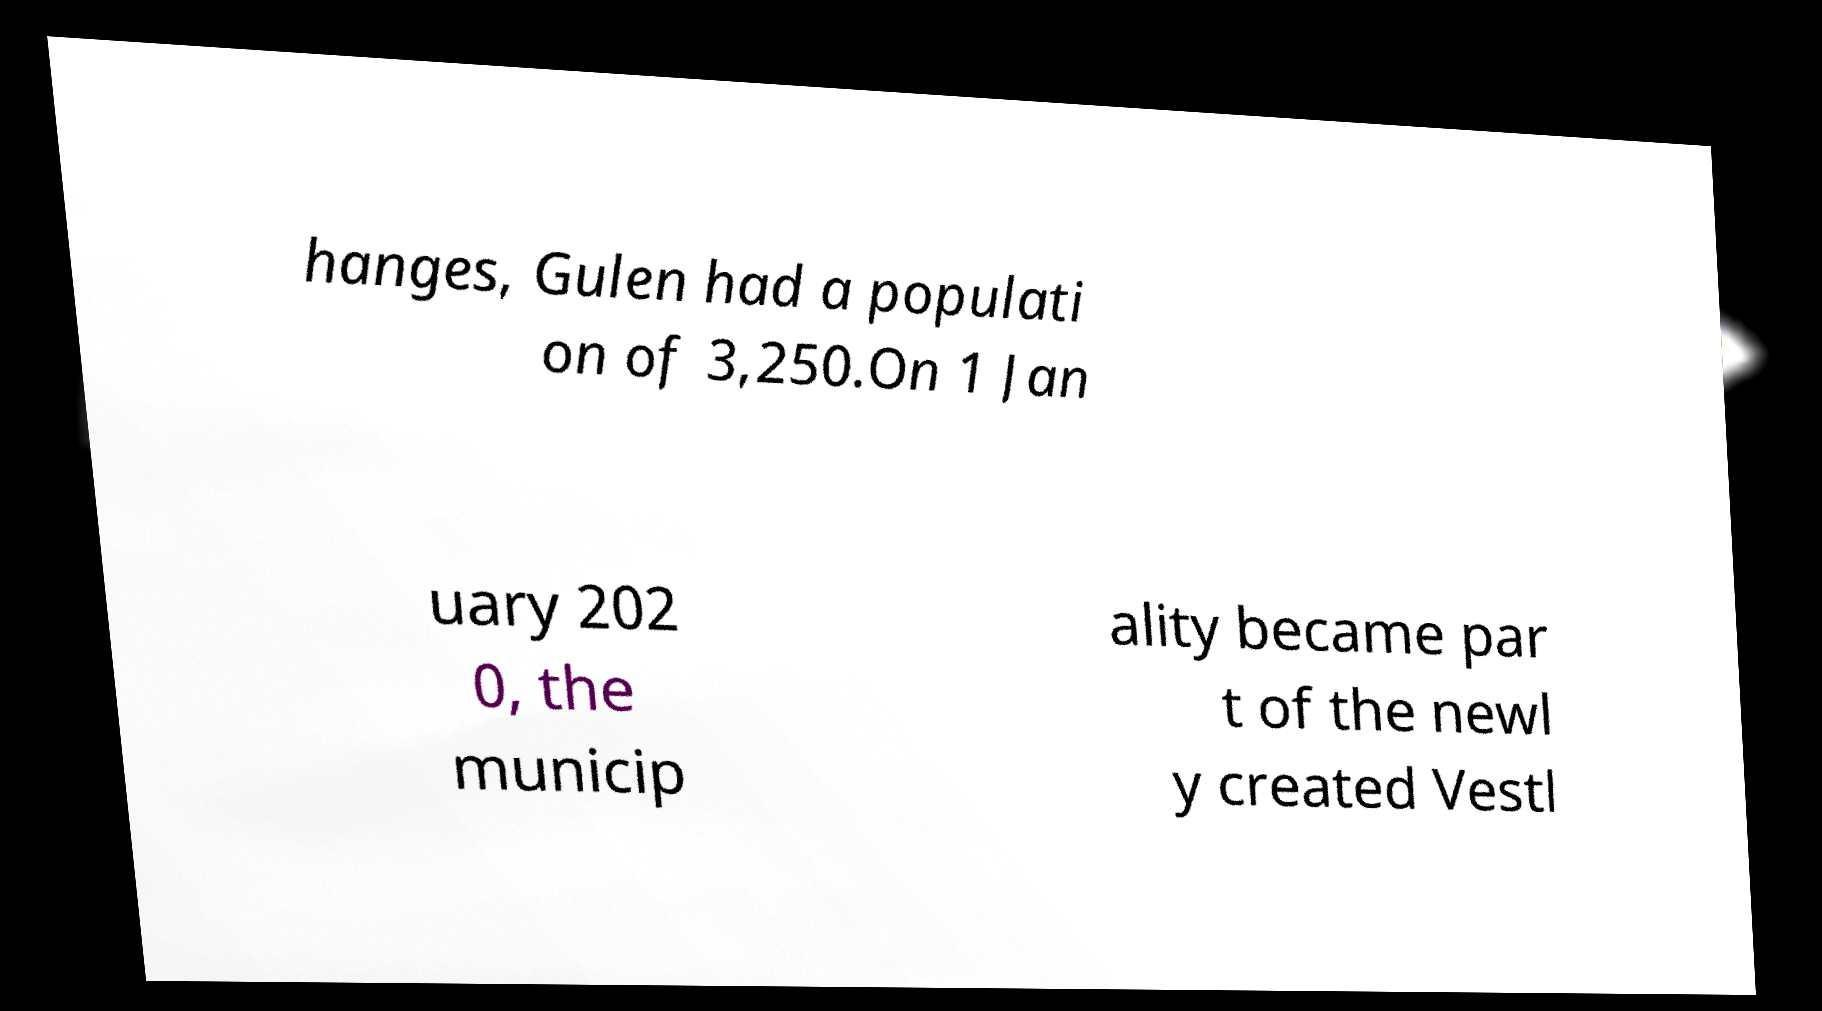What messages or text are displayed in this image? I need them in a readable, typed format. hanges, Gulen had a populati on of 3,250.On 1 Jan uary 202 0, the municip ality became par t of the newl y created Vestl 